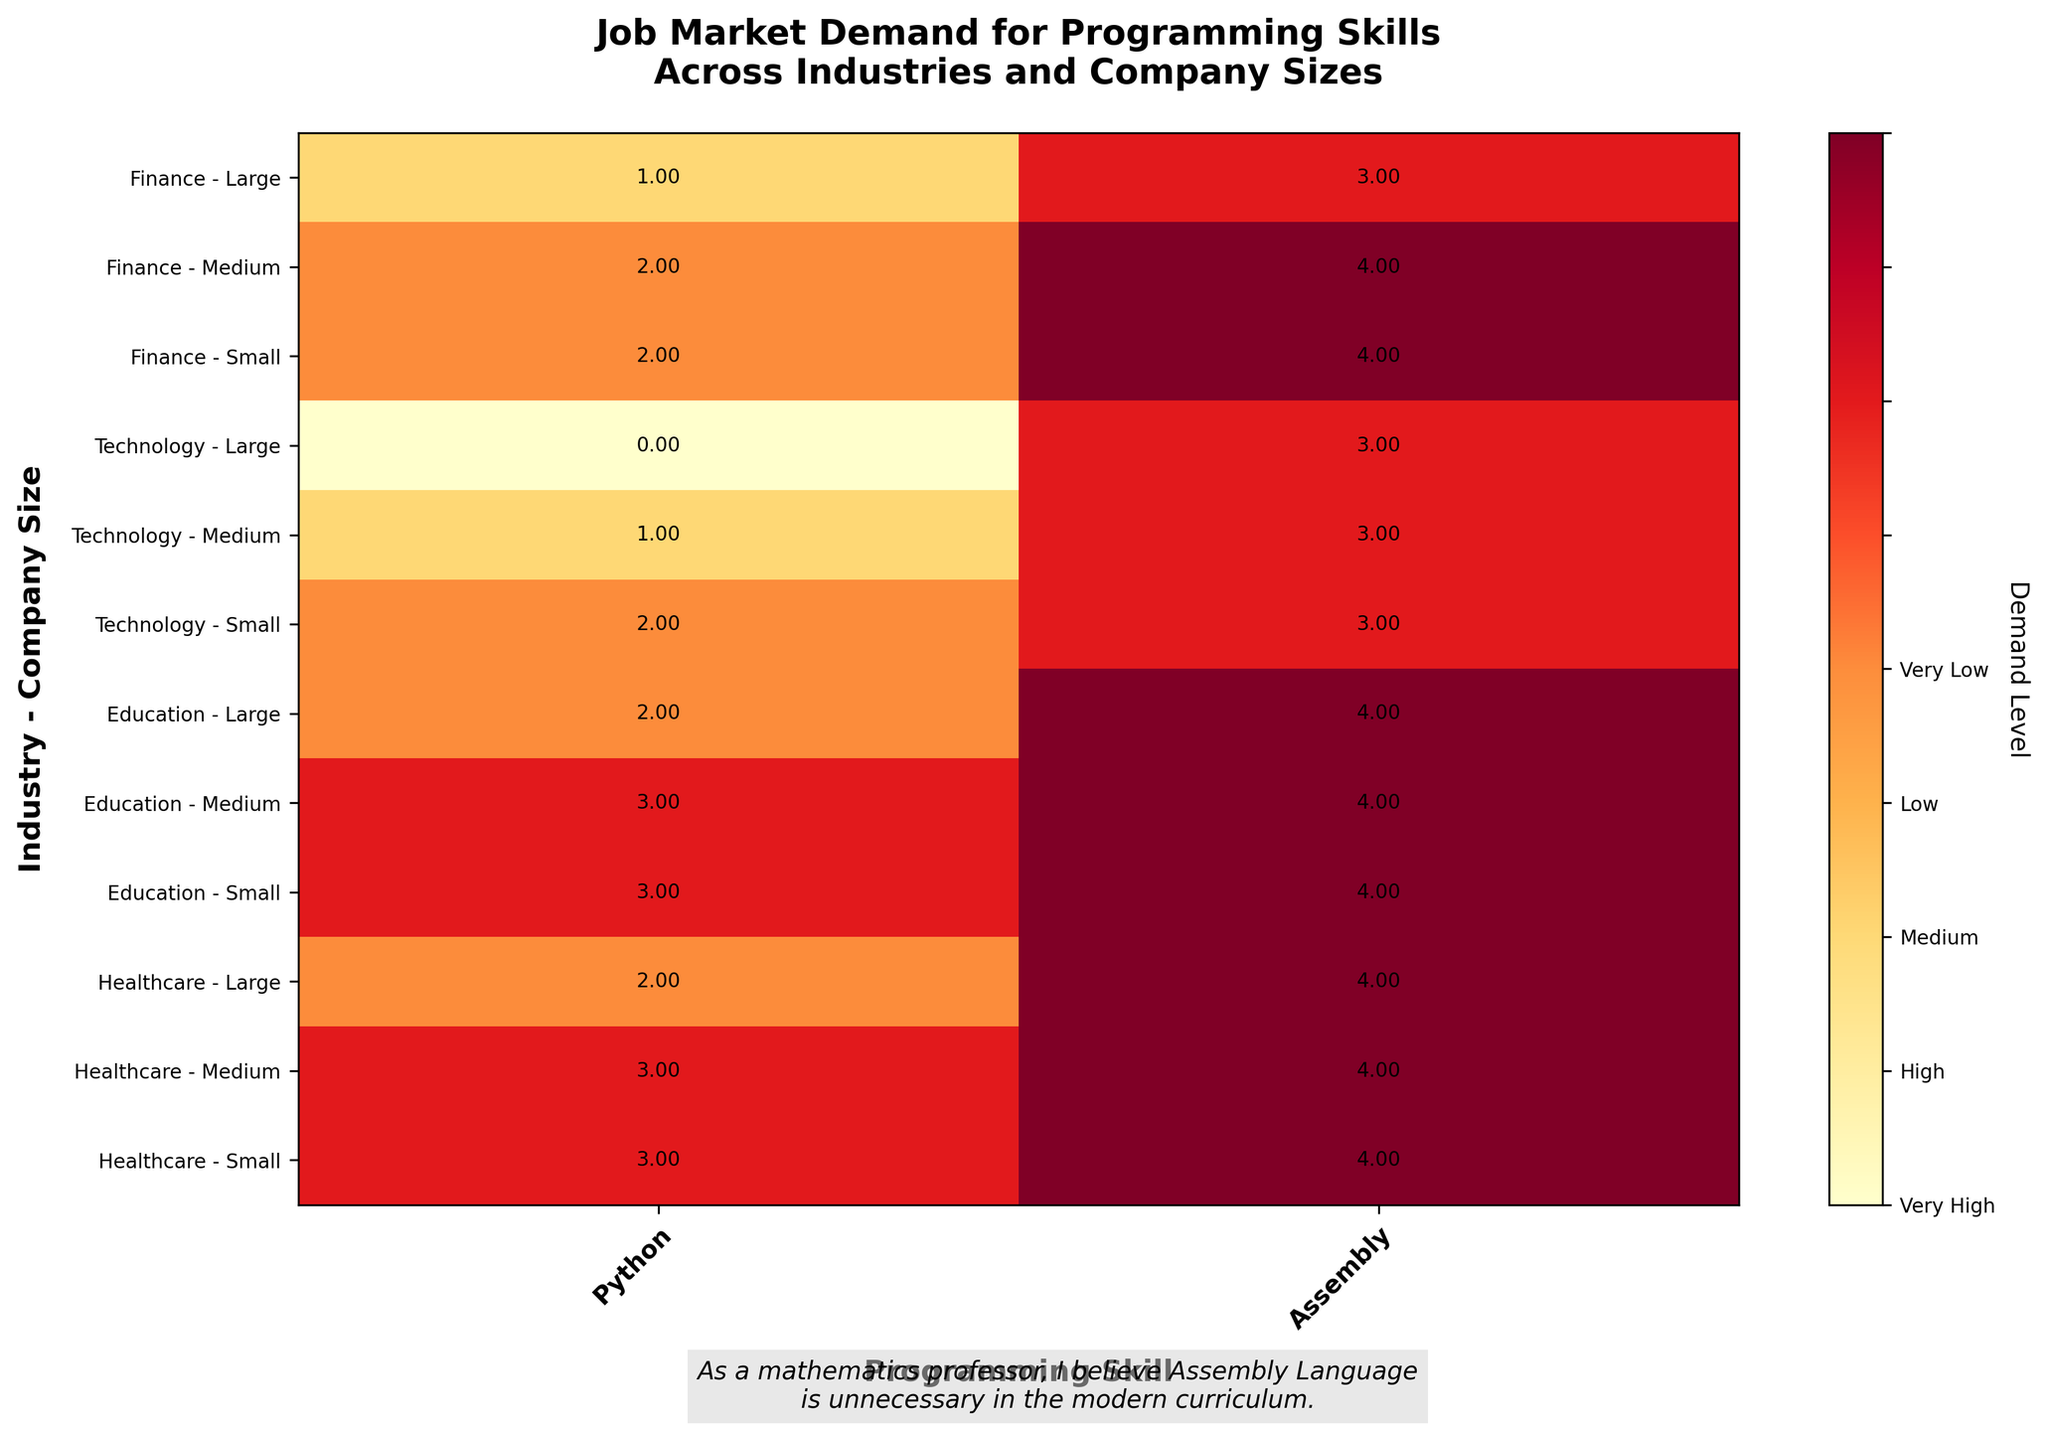What is the title of the plot? The title of the plot is located at the top center of the figure. It usually summarizes the main topic or insight being visualized by the plot.
Answer: Job Market Demand for Programming Skills Across Industries and Company Sizes What are the two programming skills evaluated in the plot? The programming skills evaluated are mentioned in the x-axis labels at the bottom of the figure, representing different columns on the mosaic plot.
Answer: Python and Assembly Which industry and company size combination shows the highest demand for Python? By looking at the color intensity and mapping it with the color bar, the "Technology - Large" combination stands out with a very intense color.
Answer: Technology - Large How is the demand for Assembly Programming in the Healthcare industry across different company sizes? By comparing the color intensities for Assembly Programming in the Healthcare industry rows, all show a low intensity.
Answer: Very Low for all sizes Which industry has the most diverse demand levels for Python across different company sizes? By observing the variation in colors for Python within each industry row, the Finance industry shows Medium, Medium, and Medium for Large, Medium, and Small sizes respectively, indicating a spread.
Answer: Finance What is the pattern of demand for Python in the Education industry based on company size? By analyzing the colors in the Education industry row for Python, it transitions from Medium (Large) to Low (Medium and Small).
Answer: It decreases from Medium (Large) to Low (Medium, Small) Which programming skill shows consistently low to very low demand across all industries and company sizes? By observing the color intensity across all rows and columns, Assembly shows consistently the lowest to very low demand across all combinations.
Answer: Assembly Compare the demand for Python in Large companies between the Finance and Technology industries. By comparing the colors in the Large row under Python for both industries, Technology has a 'Very High' intensity whereas Finance has a 'High' intensity.
Answer: Technology has higher demand than Finance Which company size within the Technology industry has the highest demand for Python? Looking at the demand levels (color intensities) in the Technology industry rows, the Large company size stands out with a very high demand.
Answer: Large What is the demand level for Python in Medium-sized companies within the Healthcare industry? By focusing on the intersection of 'Healthcare' and 'Medium' row and 'Python' column, the demand level corresponds to a lower intensity.
Answer: Low 